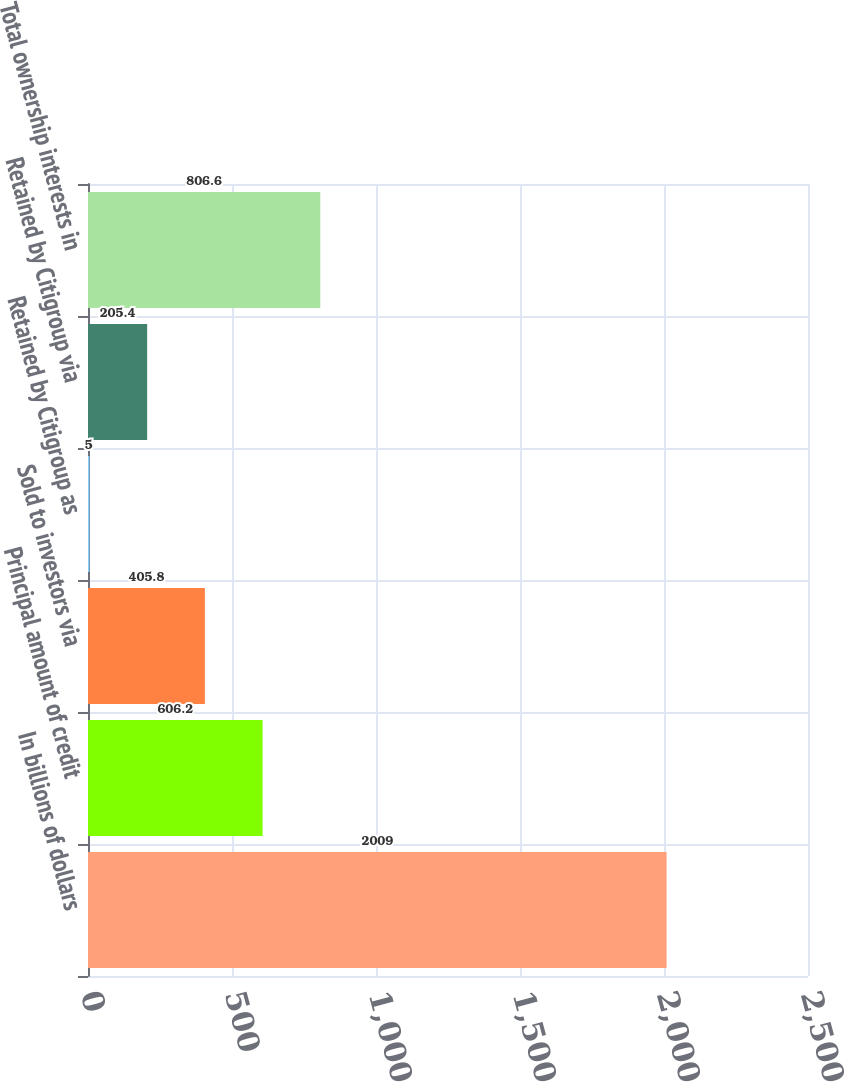<chart> <loc_0><loc_0><loc_500><loc_500><bar_chart><fcel>In billions of dollars<fcel>Principal amount of credit<fcel>Sold to investors via<fcel>Retained by Citigroup as<fcel>Retained by Citigroup via<fcel>Total ownership interests in<nl><fcel>2009<fcel>606.2<fcel>405.8<fcel>5<fcel>205.4<fcel>806.6<nl></chart> 